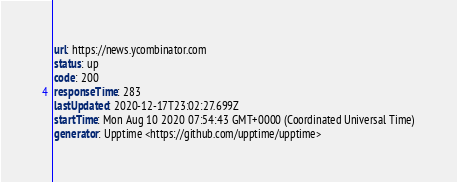Convert code to text. <code><loc_0><loc_0><loc_500><loc_500><_YAML_>url: https://news.ycombinator.com  
status: up
code: 200
responseTime: 283
lastUpdated: 2020-12-17T23:02:27.699Z
startTime: Mon Aug 10 2020 07:54:43 GMT+0000 (Coordinated Universal Time)
generator: Upptime <https://github.com/upptime/upptime>
</code> 